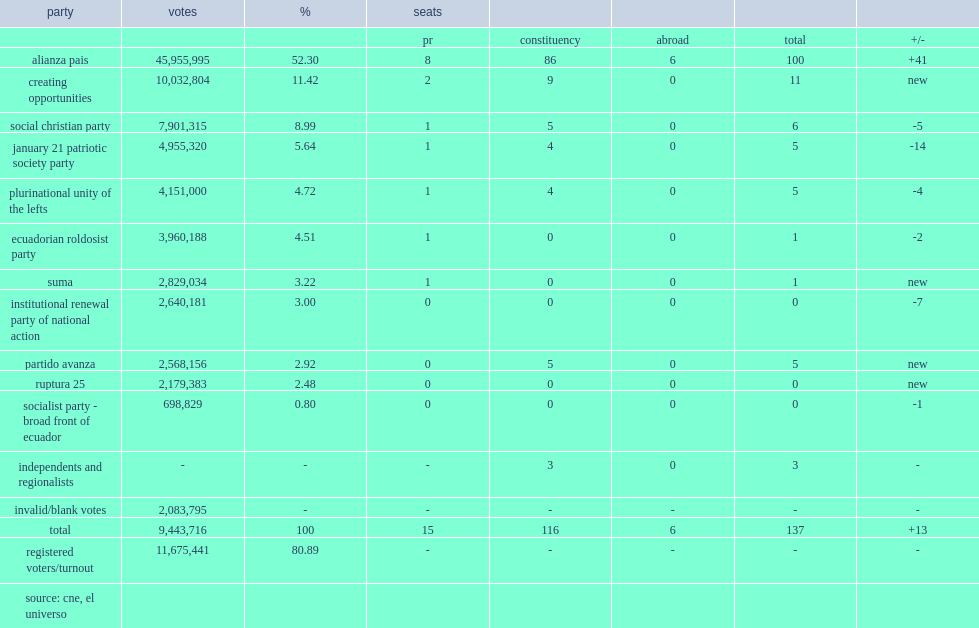How many members were elected in the national assembly elections? 137.0. 